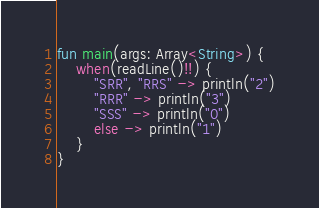Convert code to text. <code><loc_0><loc_0><loc_500><loc_500><_Kotlin_>fun main(args: Array<String>) {
    when(readLine()!!) {
        "SRR", "RRS" -> println("2")
        "RRR" -> println("3")
        "SSS" -> println("0")
        else -> println("1")
    }
}</code> 